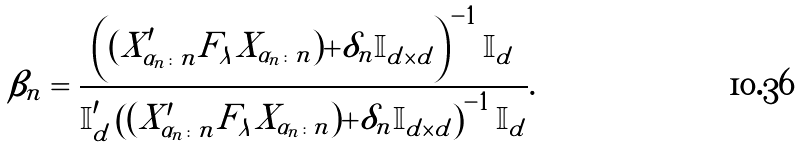Convert formula to latex. <formula><loc_0><loc_0><loc_500><loc_500>\beta _ { n } = \frac { \left ( ( X _ { \alpha _ { n } \colon n } ^ { \prime } F _ { \lambda } X _ { \alpha _ { n } \colon n } ) + \delta _ { n } \mathbb { I } _ { d \times d } \right ) ^ { - 1 } \mathbb { I } _ { d } } { \mathbb { I } _ { d } ^ { \prime } \left ( ( X _ { \alpha _ { n } \colon n } ^ { \prime } F _ { \lambda } X _ { \alpha _ { n } \colon n } ) + \delta _ { n } \mathbb { I } _ { d \times d } \right ) ^ { - 1 } \mathbb { I } _ { d } } .</formula> 